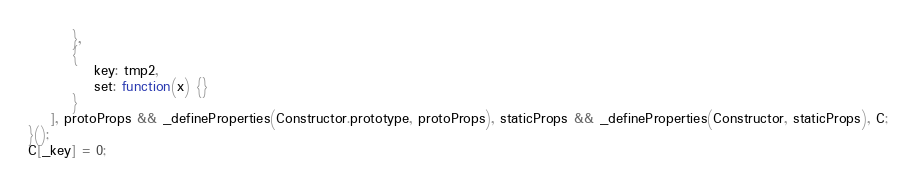Convert code to text. <code><loc_0><loc_0><loc_500><loc_500><_JavaScript_>        },
        {
            key: tmp2,
            set: function(x) {}
        }
    ], protoProps && _defineProperties(Constructor.prototype, protoProps), staticProps && _defineProperties(Constructor, staticProps), C;
}();
C[_key] = 0;
</code> 